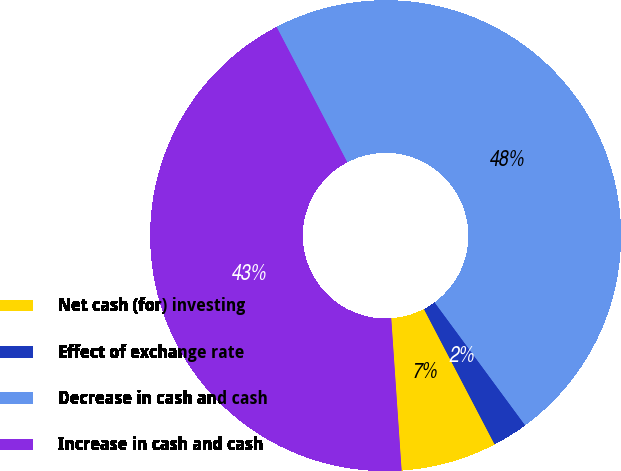<chart> <loc_0><loc_0><loc_500><loc_500><pie_chart><fcel>Net cash (for) investing<fcel>Effect of exchange rate<fcel>Decrease in cash and cash<fcel>Increase in cash and cash<nl><fcel>6.58%<fcel>2.44%<fcel>47.56%<fcel>43.42%<nl></chart> 